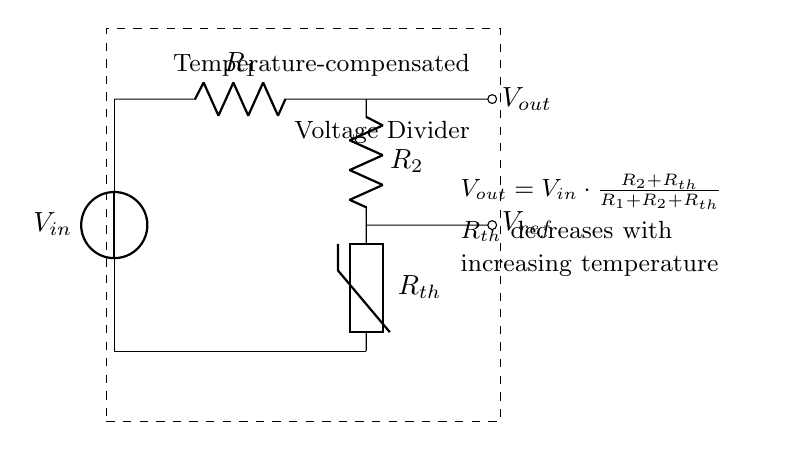What are the resistors in the circuit? The circuit contains two resistors: R1 and R2, which are part of the voltage divider configuration used to determine the output voltage.
Answer: R1, R2 What is the role of the thermistor in this circuit? The thermistor, labeled as Rth, is used for temperature compensation. Its resistance decreases with an increase in temperature, affecting the overall circuit performance and stability.
Answer: Temperature compensation What is the equation for Vout? The output voltage Vout is calculated using the formula Vout = Vin * (R2 + Rth) / (R1 + R2 + Rth), which shows the relationship between the input voltage and the resistances in the circuit.
Answer: Vout = Vin * (R2 + Rth) / (R1 + R2 + Rth) How does increasing temperature affect Rth? As temperature increases, the resistance of the thermistor (Rth) decreases, which alters the output voltage and stabilizes the circuit's frequency response.
Answer: Rth decreases What type of circuit is depicted? The circuit shown is a temperature-compensated voltage divider, which is specifically designed to stabilize frequency response in audio amplifiers.
Answer: Voltage divider 